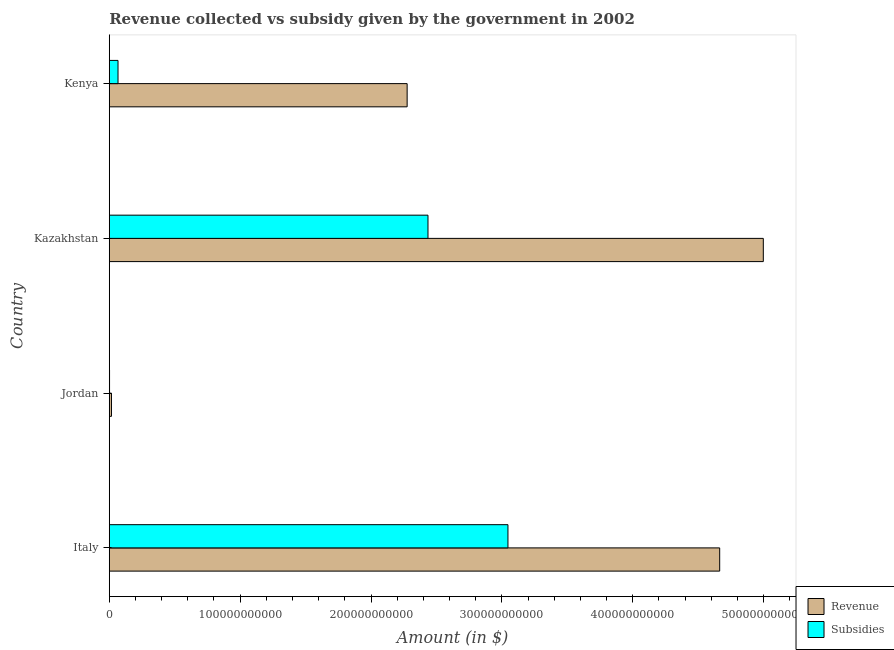How many groups of bars are there?
Provide a short and direct response. 4. Are the number of bars per tick equal to the number of legend labels?
Provide a short and direct response. Yes. Are the number of bars on each tick of the Y-axis equal?
Offer a very short reply. Yes. What is the amount of revenue collected in Kazakhstan?
Your response must be concise. 5.00e+11. Across all countries, what is the maximum amount of subsidies given?
Your response must be concise. 3.05e+11. Across all countries, what is the minimum amount of revenue collected?
Keep it short and to the point. 1.68e+09. In which country was the amount of revenue collected maximum?
Ensure brevity in your answer.  Kazakhstan. In which country was the amount of subsidies given minimum?
Give a very brief answer. Jordan. What is the total amount of subsidies given in the graph?
Your answer should be very brief. 5.55e+11. What is the difference between the amount of subsidies given in Jordan and that in Kazakhstan?
Provide a short and direct response. -2.43e+11. What is the difference between the amount of revenue collected in Kazakhstan and the amount of subsidies given in Jordan?
Offer a very short reply. 5.00e+11. What is the average amount of revenue collected per country?
Ensure brevity in your answer.  2.99e+11. What is the difference between the amount of subsidies given and amount of revenue collected in Kazakhstan?
Offer a terse response. -2.56e+11. What is the ratio of the amount of subsidies given in Italy to that in Kazakhstan?
Your answer should be compact. 1.25. Is the amount of revenue collected in Kazakhstan less than that in Kenya?
Your answer should be compact. No. What is the difference between the highest and the second highest amount of revenue collected?
Your response must be concise. 3.33e+1. What is the difference between the highest and the lowest amount of revenue collected?
Offer a very short reply. 4.98e+11. Is the sum of the amount of revenue collected in Jordan and Kazakhstan greater than the maximum amount of subsidies given across all countries?
Offer a very short reply. Yes. What does the 1st bar from the top in Italy represents?
Your response must be concise. Subsidies. What does the 2nd bar from the bottom in Kenya represents?
Keep it short and to the point. Subsidies. What is the difference between two consecutive major ticks on the X-axis?
Give a very brief answer. 1.00e+11. Does the graph contain any zero values?
Give a very brief answer. No. Does the graph contain grids?
Your answer should be very brief. No. Where does the legend appear in the graph?
Keep it short and to the point. Bottom right. What is the title of the graph?
Your answer should be compact. Revenue collected vs subsidy given by the government in 2002. Does "Domestic Liabilities" appear as one of the legend labels in the graph?
Ensure brevity in your answer.  No. What is the label or title of the X-axis?
Provide a succinct answer. Amount (in $). What is the label or title of the Y-axis?
Provide a short and direct response. Country. What is the Amount (in $) in Revenue in Italy?
Keep it short and to the point. 4.66e+11. What is the Amount (in $) in Subsidies in Italy?
Give a very brief answer. 3.05e+11. What is the Amount (in $) in Revenue in Jordan?
Provide a short and direct response. 1.68e+09. What is the Amount (in $) in Subsidies in Jordan?
Your answer should be very brief. 2.12e+08. What is the Amount (in $) of Revenue in Kazakhstan?
Your answer should be compact. 5.00e+11. What is the Amount (in $) of Subsidies in Kazakhstan?
Your answer should be very brief. 2.44e+11. What is the Amount (in $) of Revenue in Kenya?
Offer a terse response. 2.28e+11. What is the Amount (in $) of Subsidies in Kenya?
Make the answer very short. 6.68e+09. Across all countries, what is the maximum Amount (in $) in Revenue?
Give a very brief answer. 5.00e+11. Across all countries, what is the maximum Amount (in $) in Subsidies?
Your answer should be compact. 3.05e+11. Across all countries, what is the minimum Amount (in $) in Revenue?
Ensure brevity in your answer.  1.68e+09. Across all countries, what is the minimum Amount (in $) in Subsidies?
Offer a terse response. 2.12e+08. What is the total Amount (in $) of Revenue in the graph?
Your response must be concise. 1.20e+12. What is the total Amount (in $) of Subsidies in the graph?
Your answer should be compact. 5.55e+11. What is the difference between the Amount (in $) in Revenue in Italy and that in Jordan?
Give a very brief answer. 4.65e+11. What is the difference between the Amount (in $) of Subsidies in Italy and that in Jordan?
Offer a very short reply. 3.04e+11. What is the difference between the Amount (in $) in Revenue in Italy and that in Kazakhstan?
Offer a terse response. -3.33e+1. What is the difference between the Amount (in $) of Subsidies in Italy and that in Kazakhstan?
Your answer should be very brief. 6.11e+1. What is the difference between the Amount (in $) of Revenue in Italy and that in Kenya?
Give a very brief answer. 2.39e+11. What is the difference between the Amount (in $) in Subsidies in Italy and that in Kenya?
Your response must be concise. 2.98e+11. What is the difference between the Amount (in $) in Revenue in Jordan and that in Kazakhstan?
Your answer should be very brief. -4.98e+11. What is the difference between the Amount (in $) in Subsidies in Jordan and that in Kazakhstan?
Provide a succinct answer. -2.43e+11. What is the difference between the Amount (in $) of Revenue in Jordan and that in Kenya?
Provide a short and direct response. -2.26e+11. What is the difference between the Amount (in $) of Subsidies in Jordan and that in Kenya?
Ensure brevity in your answer.  -6.47e+09. What is the difference between the Amount (in $) in Revenue in Kazakhstan and that in Kenya?
Make the answer very short. 2.72e+11. What is the difference between the Amount (in $) of Subsidies in Kazakhstan and that in Kenya?
Your response must be concise. 2.37e+11. What is the difference between the Amount (in $) of Revenue in Italy and the Amount (in $) of Subsidies in Jordan?
Keep it short and to the point. 4.66e+11. What is the difference between the Amount (in $) in Revenue in Italy and the Amount (in $) in Subsidies in Kazakhstan?
Ensure brevity in your answer.  2.23e+11. What is the difference between the Amount (in $) in Revenue in Italy and the Amount (in $) in Subsidies in Kenya?
Give a very brief answer. 4.60e+11. What is the difference between the Amount (in $) of Revenue in Jordan and the Amount (in $) of Subsidies in Kazakhstan?
Give a very brief answer. -2.42e+11. What is the difference between the Amount (in $) of Revenue in Jordan and the Amount (in $) of Subsidies in Kenya?
Your response must be concise. -5.01e+09. What is the difference between the Amount (in $) in Revenue in Kazakhstan and the Amount (in $) in Subsidies in Kenya?
Provide a short and direct response. 4.93e+11. What is the average Amount (in $) in Revenue per country?
Ensure brevity in your answer.  2.99e+11. What is the average Amount (in $) in Subsidies per country?
Offer a terse response. 1.39e+11. What is the difference between the Amount (in $) in Revenue and Amount (in $) in Subsidies in Italy?
Offer a terse response. 1.62e+11. What is the difference between the Amount (in $) of Revenue and Amount (in $) of Subsidies in Jordan?
Offer a very short reply. 1.46e+09. What is the difference between the Amount (in $) of Revenue and Amount (in $) of Subsidies in Kazakhstan?
Ensure brevity in your answer.  2.56e+11. What is the difference between the Amount (in $) in Revenue and Amount (in $) in Subsidies in Kenya?
Give a very brief answer. 2.21e+11. What is the ratio of the Amount (in $) of Revenue in Italy to that in Jordan?
Your answer should be very brief. 278.24. What is the ratio of the Amount (in $) of Subsidies in Italy to that in Jordan?
Offer a very short reply. 1438.99. What is the ratio of the Amount (in $) of Revenue in Italy to that in Kazakhstan?
Your response must be concise. 0.93. What is the ratio of the Amount (in $) in Subsidies in Italy to that in Kazakhstan?
Ensure brevity in your answer.  1.25. What is the ratio of the Amount (in $) in Revenue in Italy to that in Kenya?
Your response must be concise. 2.05. What is the ratio of the Amount (in $) in Subsidies in Italy to that in Kenya?
Ensure brevity in your answer.  45.59. What is the ratio of the Amount (in $) in Revenue in Jordan to that in Kazakhstan?
Give a very brief answer. 0. What is the ratio of the Amount (in $) of Subsidies in Jordan to that in Kazakhstan?
Provide a short and direct response. 0. What is the ratio of the Amount (in $) in Revenue in Jordan to that in Kenya?
Provide a succinct answer. 0.01. What is the ratio of the Amount (in $) in Subsidies in Jordan to that in Kenya?
Offer a very short reply. 0.03. What is the ratio of the Amount (in $) in Revenue in Kazakhstan to that in Kenya?
Your answer should be very brief. 2.2. What is the ratio of the Amount (in $) in Subsidies in Kazakhstan to that in Kenya?
Provide a short and direct response. 36.45. What is the difference between the highest and the second highest Amount (in $) in Revenue?
Provide a short and direct response. 3.33e+1. What is the difference between the highest and the second highest Amount (in $) in Subsidies?
Keep it short and to the point. 6.11e+1. What is the difference between the highest and the lowest Amount (in $) of Revenue?
Your response must be concise. 4.98e+11. What is the difference between the highest and the lowest Amount (in $) in Subsidies?
Ensure brevity in your answer.  3.04e+11. 